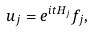Convert formula to latex. <formula><loc_0><loc_0><loc_500><loc_500>u _ { j } = e ^ { i t H _ { j } } f _ { j } ,</formula> 